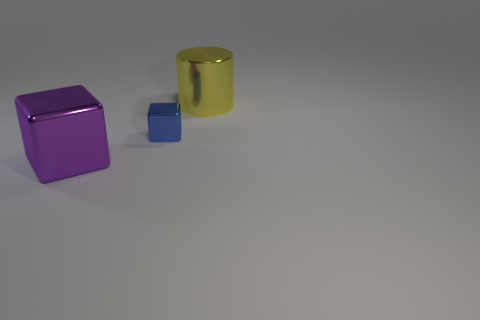Add 2 tiny red cylinders. How many objects exist? 5 Subtract all cylinders. How many objects are left? 2 Subtract all large purple metal objects. Subtract all large yellow cylinders. How many objects are left? 1 Add 1 tiny objects. How many tiny objects are left? 2 Add 2 big purple things. How many big purple things exist? 3 Subtract 0 red cubes. How many objects are left? 3 